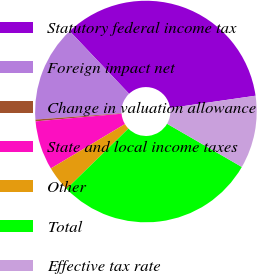<chart> <loc_0><loc_0><loc_500><loc_500><pie_chart><fcel>Statutory federal income tax<fcel>Foreign impact net<fcel>Change in valuation allowance<fcel>State and local income taxes<fcel>Other<fcel>Total<fcel>Effective tax rate<nl><fcel>34.8%<fcel>14.08%<fcel>0.26%<fcel>7.17%<fcel>3.71%<fcel>29.36%<fcel>10.62%<nl></chart> 